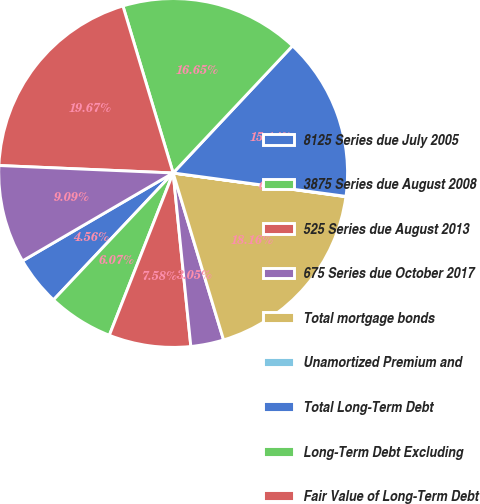<chart> <loc_0><loc_0><loc_500><loc_500><pie_chart><fcel>8125 Series due July 2005<fcel>3875 Series due August 2008<fcel>525 Series due August 2013<fcel>675 Series due October 2017<fcel>Total mortgage bonds<fcel>Unamortized Premium and<fcel>Total Long-Term Debt<fcel>Long-Term Debt Excluding<fcel>Fair Value of Long-Term Debt<fcel>4875 Series due October 2007<nl><fcel>4.56%<fcel>6.07%<fcel>7.58%<fcel>3.05%<fcel>18.16%<fcel>0.03%<fcel>15.14%<fcel>16.65%<fcel>19.67%<fcel>9.09%<nl></chart> 